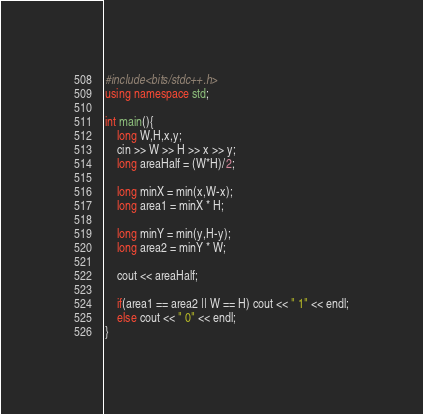Convert code to text. <code><loc_0><loc_0><loc_500><loc_500><_C++_>#include<bits/stdc++.h>
using namespace std;

int main(){
    long W,H,x,y;
    cin >> W >> H >> x >> y;
    long areaHalf = (W*H)/2;

    long minX = min(x,W-x);
    long area1 = minX * H;

    long minY = min(y,H-y);
    long area2 = minY * W;
    
    cout << areaHalf;

    if(area1 == area2 || W == H) cout << " 1" << endl;
    else cout << " 0" << endl;
}</code> 